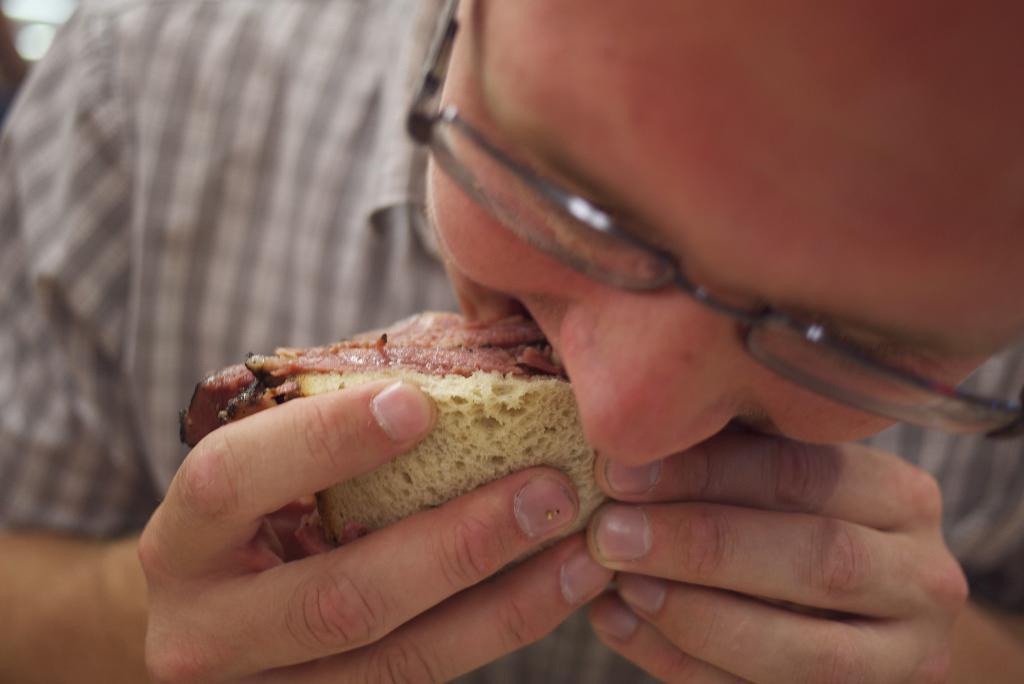Please provide a concise description of this image. In the image there is a man eating a sandwich. 